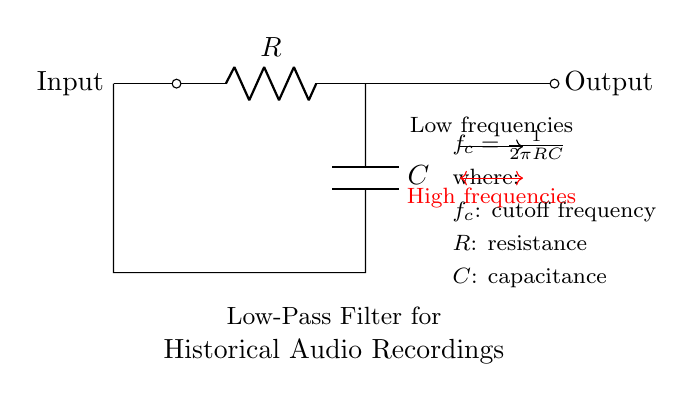What is the component connected to the input? The component connected to the input is a resistor, as indicated by the label R in the circuit.
Answer: Resistor What is the function of the capacitor in this circuit? The capacitor functions to block high-frequency signals while allowing low-frequency signals to pass through, which is characteristic of a low-pass filter.
Answer: Block high frequencies What is the cutoff frequency formula provided in the circuit? The cutoff frequency formula given in the circuit is f_c = 1/(2πRC), indicating that the cutoff frequency depends on the resistance and capacitance values.
Answer: f_c = 1/(2πRC) What happens to high frequencies in this filter circuit? High frequencies are attenuated, meaning they are reduced significantly in amplitude when passing through the circuit.
Answer: Attenuated What does the output node indicate in this low-pass filter? The output node indicates where the filtered signal, primarily low frequencies, is taken from after the input has passed through the resistor and capacitor.
Answer: Filtered low frequencies What relationship does increasing the resistance have on the cutoff frequency? Increasing the resistance will decrease the cutoff frequency, as they are inversely related in the formula f_c = 1/(2πRC).
Answer: Decrease cutoff frequency 